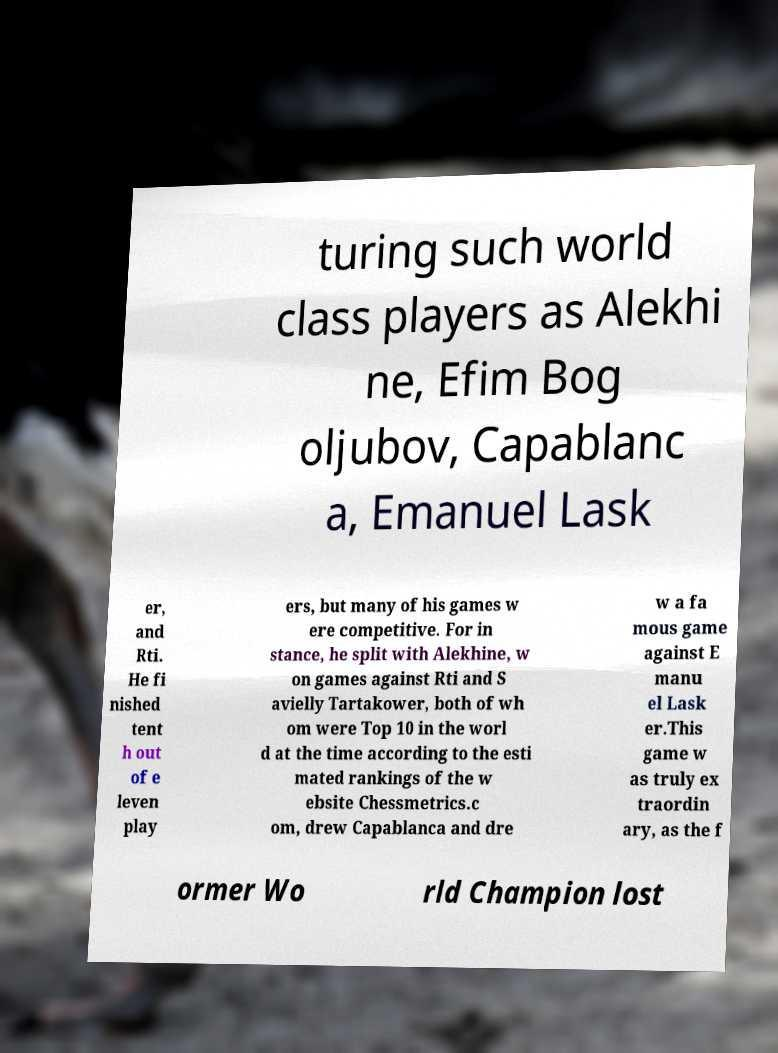There's text embedded in this image that I need extracted. Can you transcribe it verbatim? turing such world class players as Alekhi ne, Efim Bog oljubov, Capablanc a, Emanuel Lask er, and Rti. He fi nished tent h out of e leven play ers, but many of his games w ere competitive. For in stance, he split with Alekhine, w on games against Rti and S avielly Tartakower, both of wh om were Top 10 in the worl d at the time according to the esti mated rankings of the w ebsite Chessmetrics.c om, drew Capablanca and dre w a fa mous game against E manu el Lask er.This game w as truly ex traordin ary, as the f ormer Wo rld Champion lost 